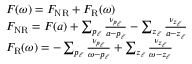<formula> <loc_0><loc_0><loc_500><loc_500>\begin{array} { r } { \begin{array} { r l } & { F ( \omega ) = F _ { N R } + F _ { R } ( \omega ) } \\ & { F _ { N R } = F ( a ) + \sum _ { p _ { \ell } } \frac { \nu _ { p _ { \ell } } } { a - p _ { \ell } } - \sum _ { z _ { \ell } } \frac { \nu _ { z _ { \ell } } } { a - z _ { \ell } } } \\ & { F _ { R } ( \omega ) = - \sum _ { p _ { \ell } } \frac { \nu _ { p _ { \ell } } } { \omega - p _ { \ell } } + \sum _ { z _ { \ell } } \frac { \nu _ { z _ { \ell } } } { \omega - z _ { \ell } } } \end{array} } \end{array}</formula> 